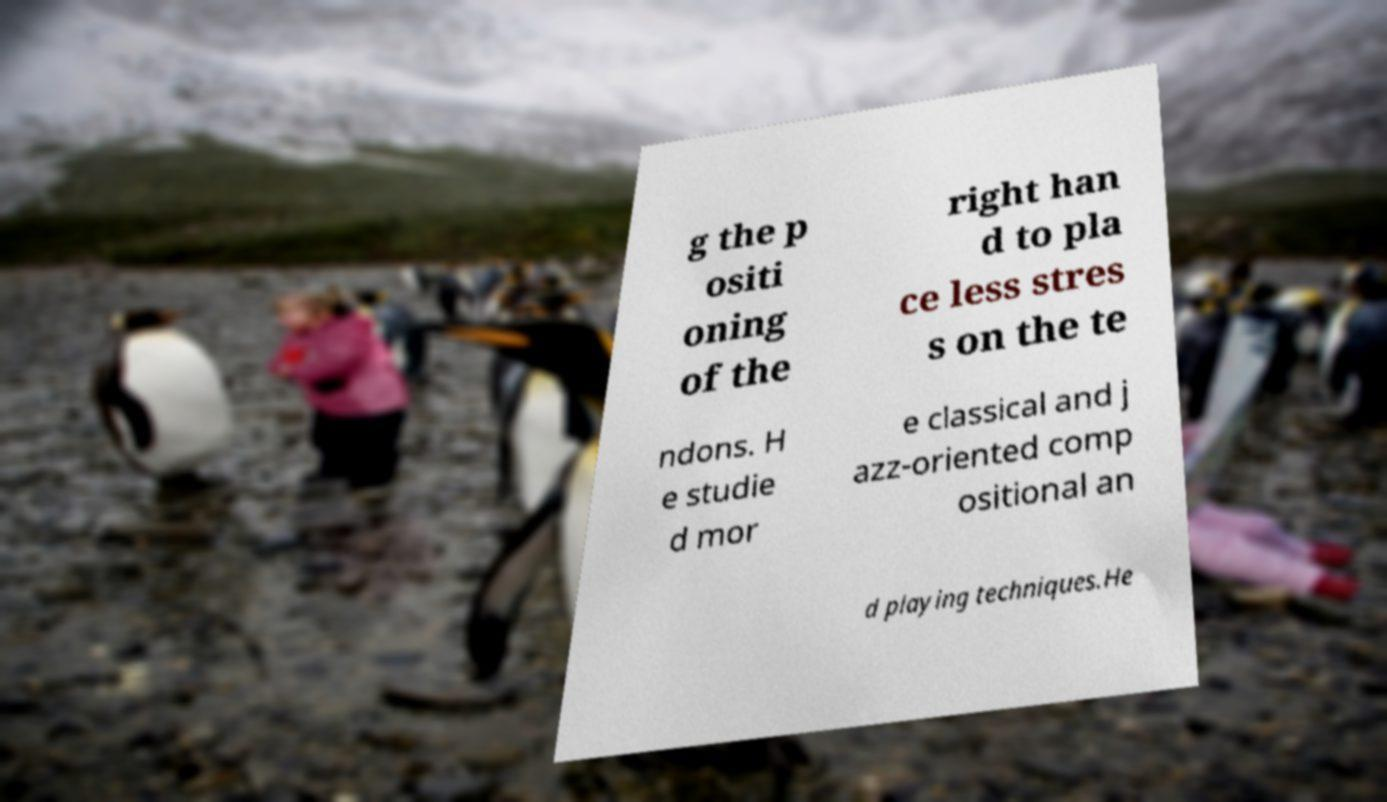Could you assist in decoding the text presented in this image and type it out clearly? g the p ositi oning of the right han d to pla ce less stres s on the te ndons. H e studie d mor e classical and j azz-oriented comp ositional an d playing techniques.He 